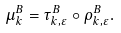Convert formula to latex. <formula><loc_0><loc_0><loc_500><loc_500>\mu ^ { B } _ { k } = \tau ^ { B } _ { k , \varepsilon } \circ \rho ^ { B } _ { k , \varepsilon } .</formula> 